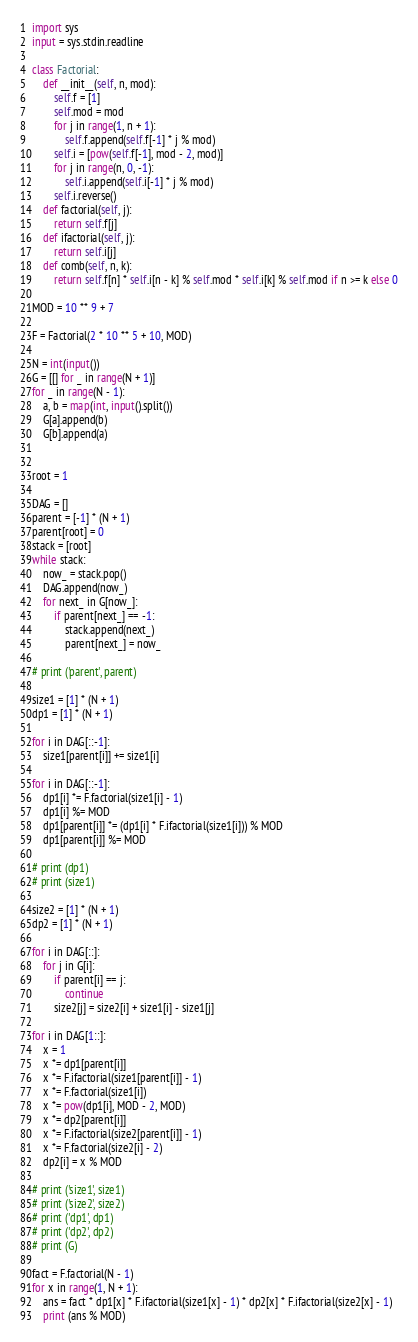<code> <loc_0><loc_0><loc_500><loc_500><_Python_>import sys
input = sys.stdin.readline

class Factorial:
    def __init__(self, n, mod):
        self.f = [1]
        self.mod = mod
        for j in range(1, n + 1):
            self.f.append(self.f[-1] * j % mod)
        self.i = [pow(self.f[-1], mod - 2, mod)]
        for j in range(n, 0, -1):
            self.i.append(self.i[-1] * j % mod)
        self.i.reverse()
    def factorial(self, j):
        return self.f[j]
    def ifactorial(self, j):
        return self.i[j]
    def comb(self, n, k):
        return self.f[n] * self.i[n - k] % self.mod * self.i[k] % self.mod if n >= k else 0

MOD = 10 ** 9 + 7

F = Factorial(2 * 10 ** 5 + 10, MOD)

N = int(input())
G = [[] for _ in range(N + 1)]
for _ in range(N - 1):
    a, b = map(int, input().split())
    G[a].append(b)
    G[b].append(a)


root = 1

DAG = []
parent = [-1] * (N + 1)
parent[root] = 0
stack = [root]
while stack:
    now_ = stack.pop()
    DAG.append(now_)
    for next_ in G[now_]:
        if parent[next_] == -1:
            stack.append(next_)
            parent[next_] = now_

# print ('parent', parent)

size1 = [1] * (N + 1)
dp1 = [1] * (N + 1)

for i in DAG[::-1]:
    size1[parent[i]] += size1[i]

for i in DAG[::-1]:
    dp1[i] *= F.factorial(size1[i] - 1)
    dp1[i] %= MOD
    dp1[parent[i]] *= (dp1[i] * F.ifactorial(size1[i])) % MOD
    dp1[parent[i]] %= MOD

# print (dp1)
# print (size1)

size2 = [1] * (N + 1)
dp2 = [1] * (N + 1)

for i in DAG[::]:
    for j in G[i]:
        if parent[i] == j:
            continue
        size2[j] = size2[i] + size1[i] - size1[j]  

for i in DAG[1::]:
    x = 1
    x *= dp1[parent[i]]
    x *= F.ifactorial(size1[parent[i]] - 1)
    x *= F.factorial(size1[i])
    x *= pow(dp1[i], MOD - 2, MOD)
    x *= dp2[parent[i]]
    x *= F.ifactorial(size2[parent[i]] - 1)
    x *= F.factorial(size2[i] - 2)
    dp2[i] = x % MOD

# print ('size1', size1)
# print ('size2', size2)
# print ('dp1', dp1)
# print ('dp2', dp2)
# print (G)

fact = F.factorial(N - 1)
for x in range(1, N + 1):
    ans = fact * dp1[x] * F.ifactorial(size1[x] - 1) * dp2[x] * F.ifactorial(size2[x] - 1)
    print (ans % MOD)
</code> 